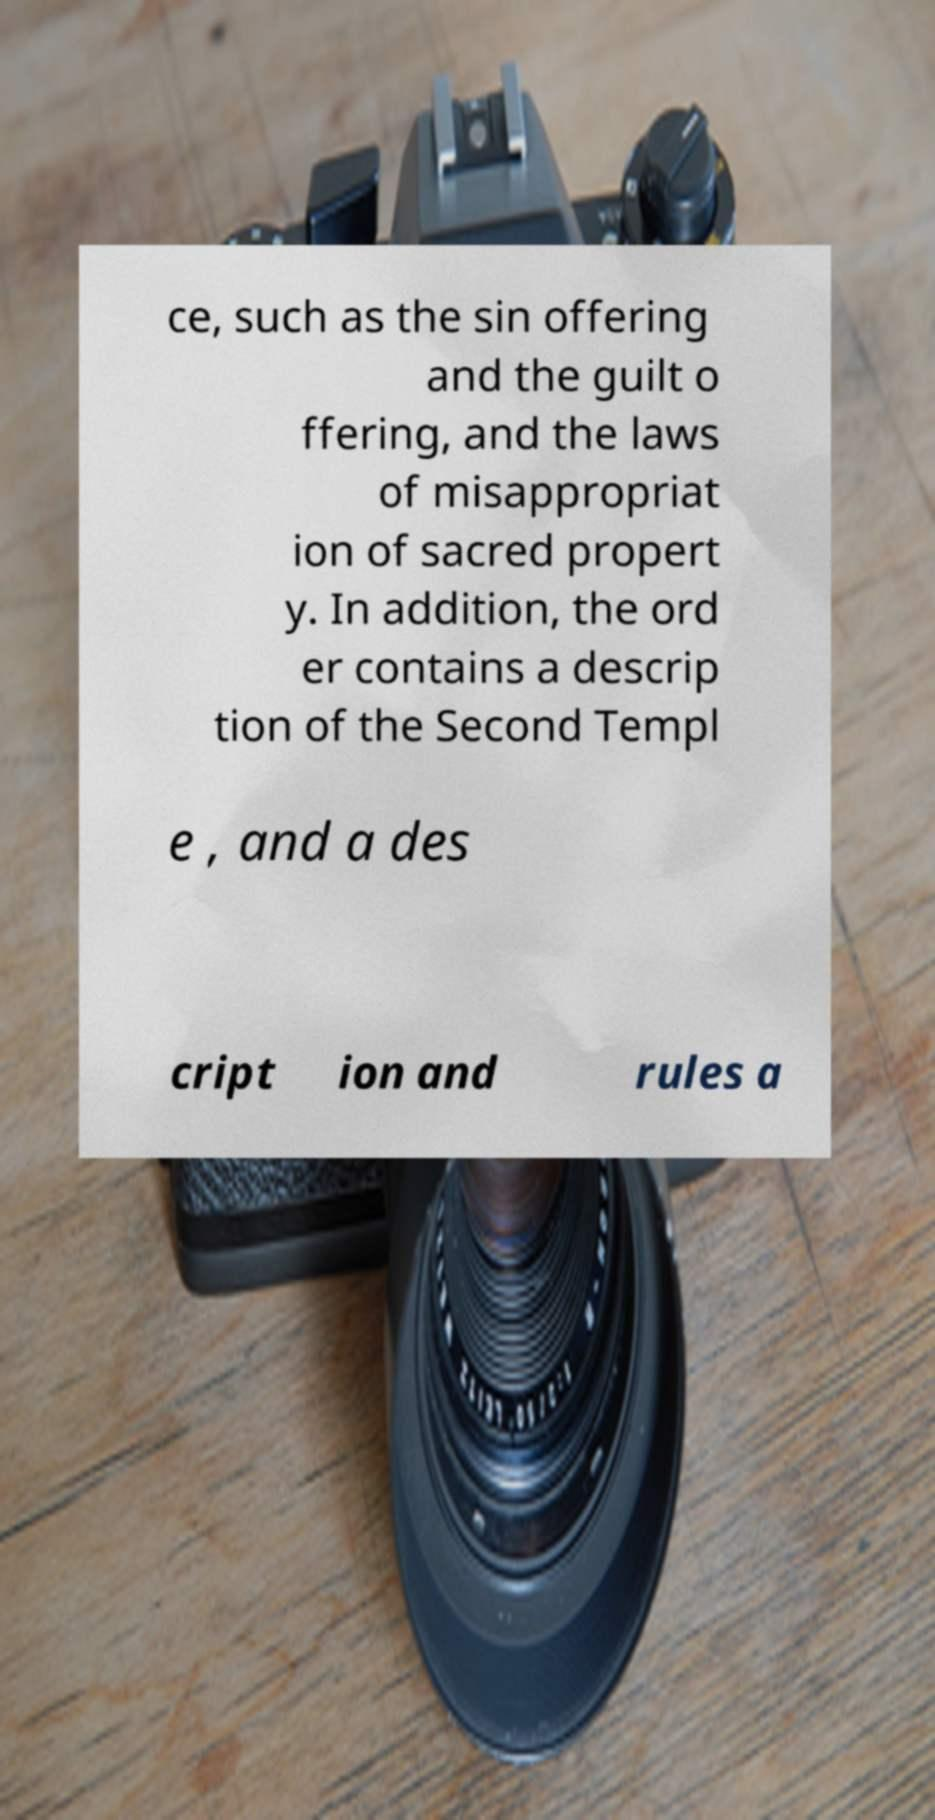What messages or text are displayed in this image? I need them in a readable, typed format. ce, such as the sin offering and the guilt o ffering, and the laws of misappropriat ion of sacred propert y. In addition, the ord er contains a descrip tion of the Second Templ e , and a des cript ion and rules a 